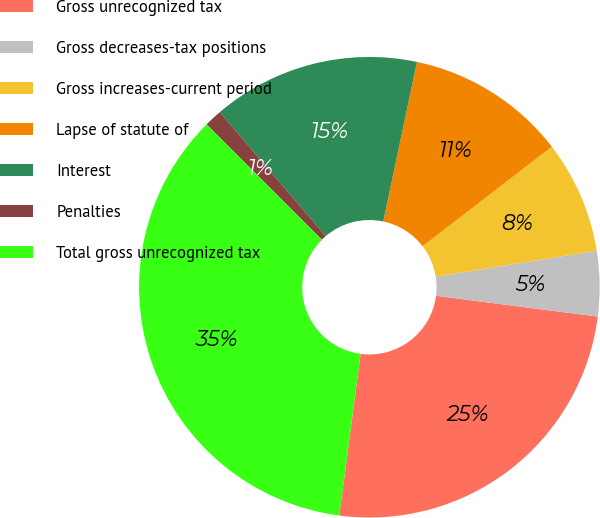<chart> <loc_0><loc_0><loc_500><loc_500><pie_chart><fcel>Gross unrecognized tax<fcel>Gross decreases-tax positions<fcel>Gross increases-current period<fcel>Lapse of statute of<fcel>Interest<fcel>Penalties<fcel>Total gross unrecognized tax<nl><fcel>25.05%<fcel>4.57%<fcel>7.91%<fcel>11.24%<fcel>14.57%<fcel>1.24%<fcel>35.42%<nl></chart> 